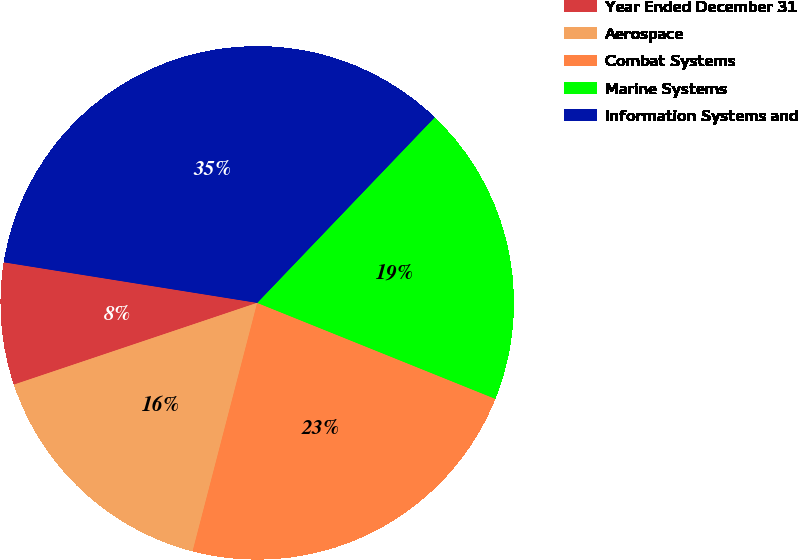Convert chart to OTSL. <chart><loc_0><loc_0><loc_500><loc_500><pie_chart><fcel>Year Ended December 31<fcel>Aerospace<fcel>Combat Systems<fcel>Marine Systems<fcel>Information Systems and<nl><fcel>7.69%<fcel>15.79%<fcel>22.95%<fcel>18.95%<fcel>34.62%<nl></chart> 